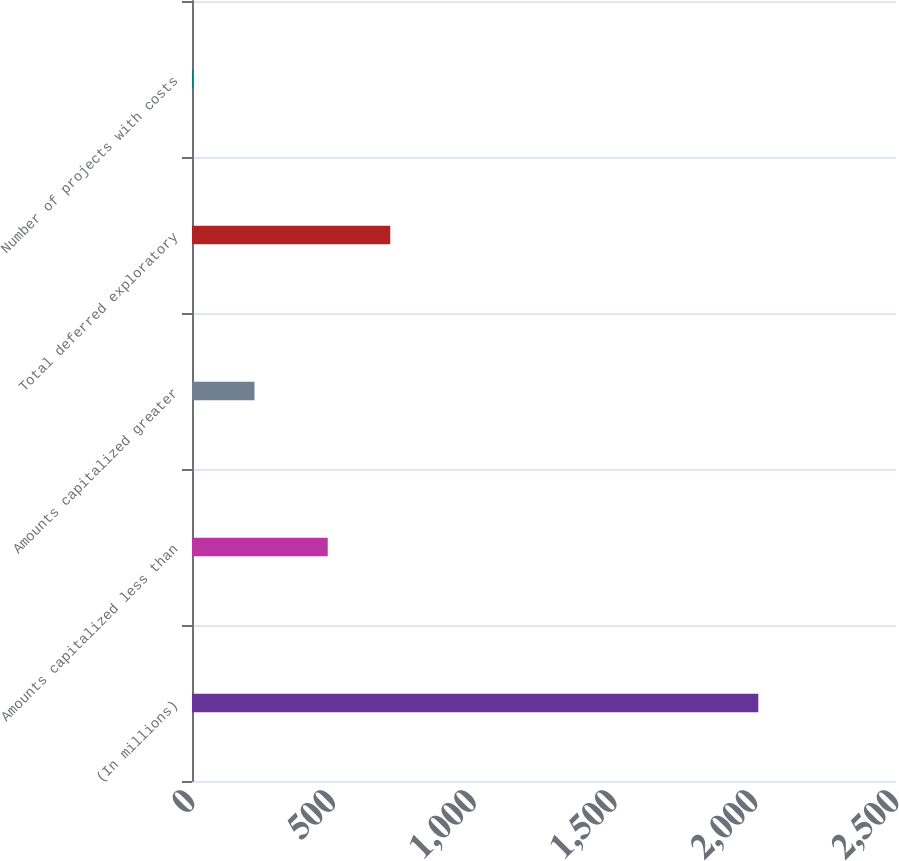Convert chart to OTSL. <chart><loc_0><loc_0><loc_500><loc_500><bar_chart><fcel>(In millions)<fcel>Amounts capitalized less than<fcel>Amounts capitalized greater<fcel>Total deferred exploratory<fcel>Number of projects with costs<nl><fcel>2011<fcel>482<fcel>222<fcel>704<fcel>5<nl></chart> 